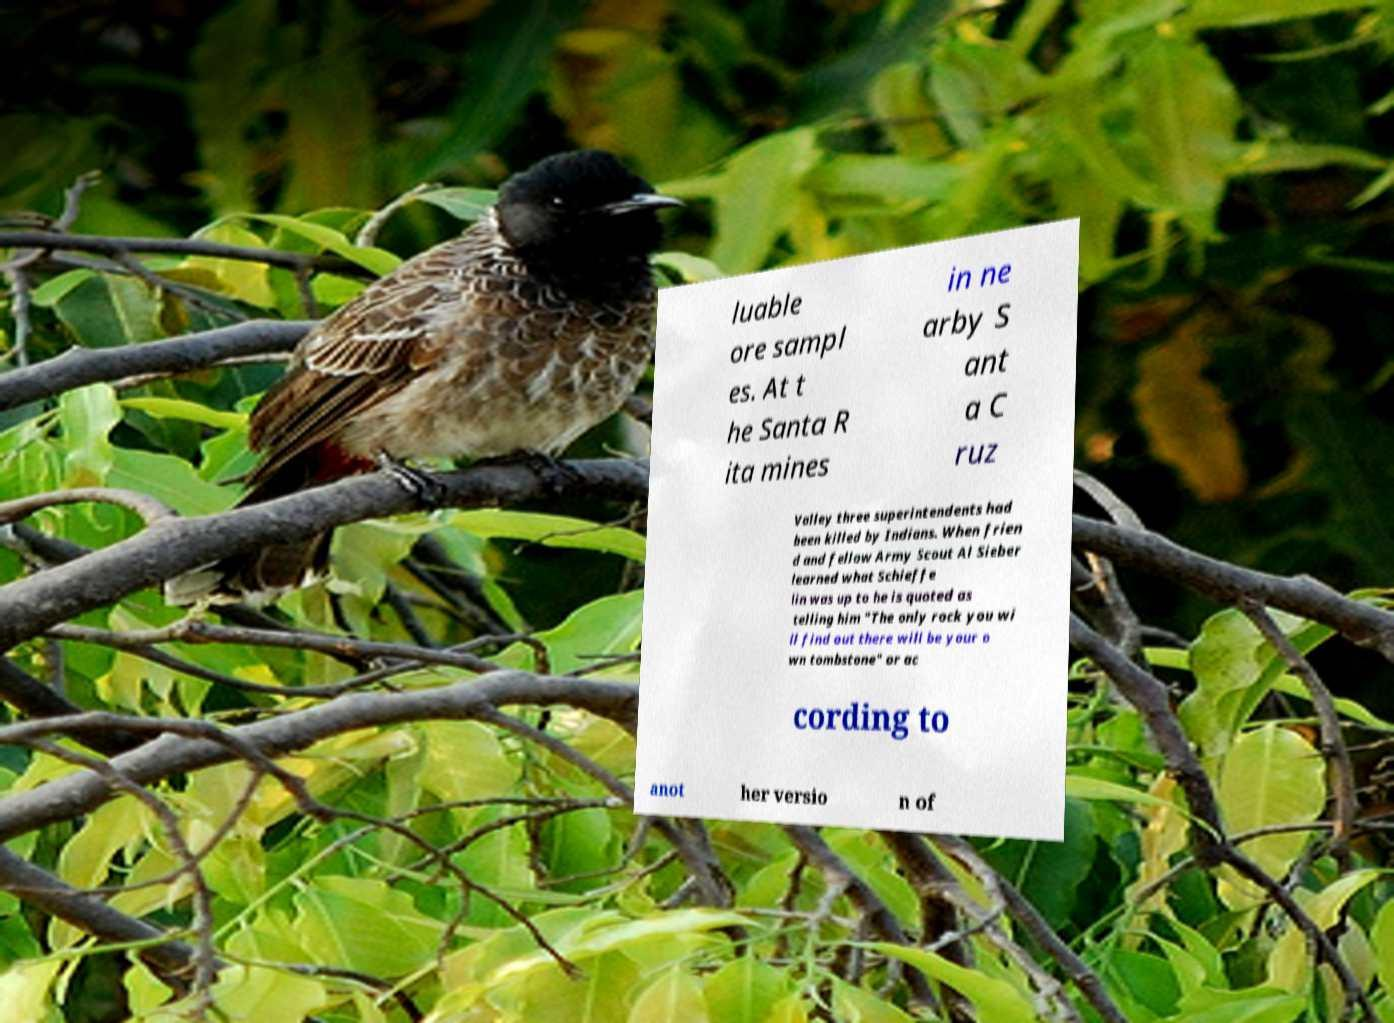Please read and relay the text visible in this image. What does it say? luable ore sampl es. At t he Santa R ita mines in ne arby S ant a C ruz Valley three superintendents had been killed by Indians. When frien d and fellow Army Scout Al Sieber learned what Schieffe lin was up to he is quoted as telling him "The only rock you wi ll find out there will be your o wn tombstone" or ac cording to anot her versio n of 